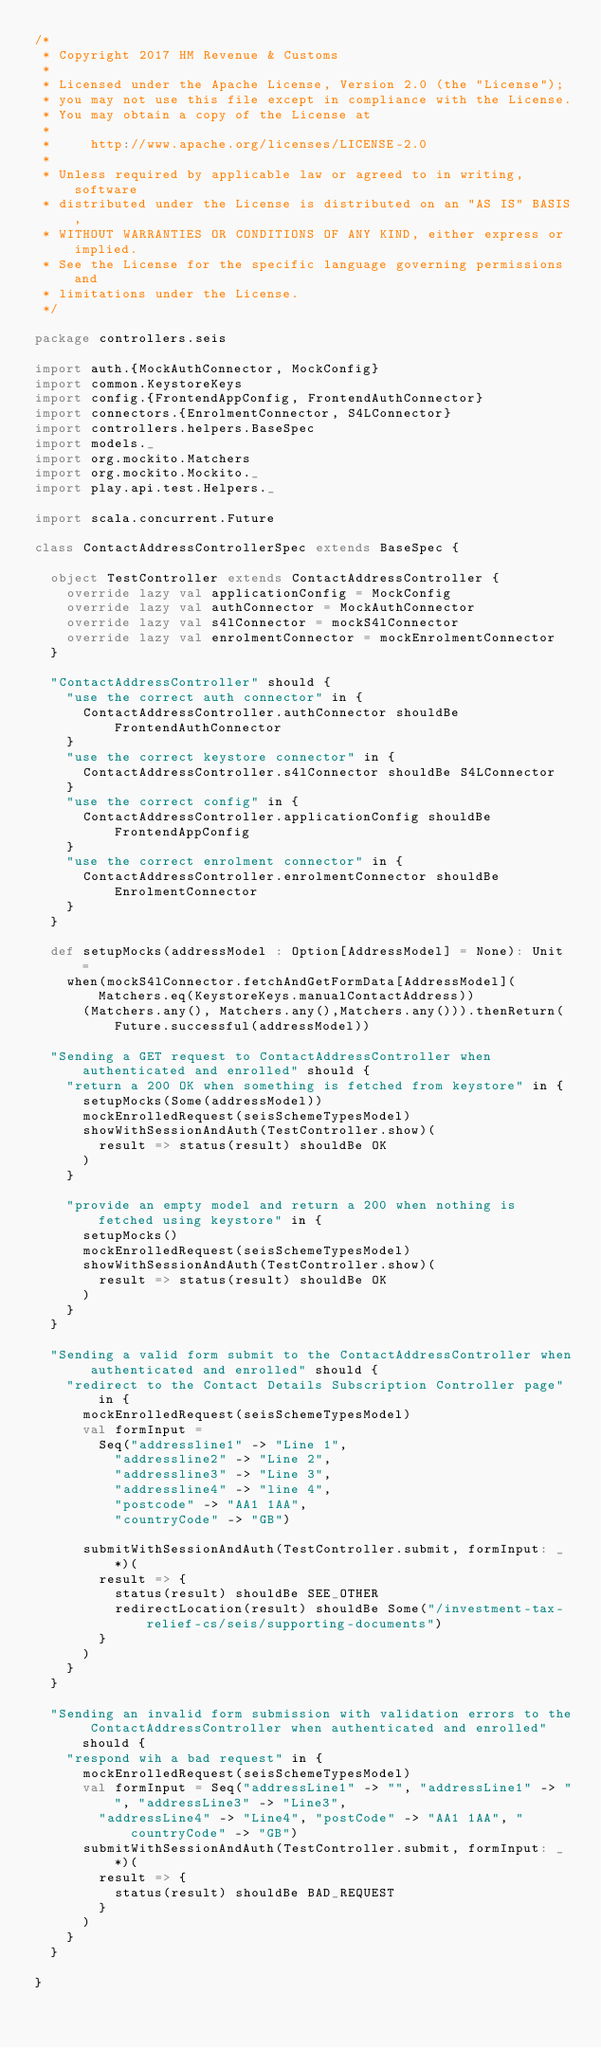<code> <loc_0><loc_0><loc_500><loc_500><_Scala_>/*
 * Copyright 2017 HM Revenue & Customs
 *
 * Licensed under the Apache License, Version 2.0 (the "License");
 * you may not use this file except in compliance with the License.
 * You may obtain a copy of the License at
 *
 *     http://www.apache.org/licenses/LICENSE-2.0
 *
 * Unless required by applicable law or agreed to in writing, software
 * distributed under the License is distributed on an "AS IS" BASIS,
 * WITHOUT WARRANTIES OR CONDITIONS OF ANY KIND, either express or implied.
 * See the License for the specific language governing permissions and
 * limitations under the License.
 */

package controllers.seis

import auth.{MockAuthConnector, MockConfig}
import common.KeystoreKeys
import config.{FrontendAppConfig, FrontendAuthConnector}
import connectors.{EnrolmentConnector, S4LConnector}
import controllers.helpers.BaseSpec
import models._
import org.mockito.Matchers
import org.mockito.Mockito._
import play.api.test.Helpers._

import scala.concurrent.Future

class ContactAddressControllerSpec extends BaseSpec {

  object TestController extends ContactAddressController {
    override lazy val applicationConfig = MockConfig
    override lazy val authConnector = MockAuthConnector
    override lazy val s4lConnector = mockS4lConnector
    override lazy val enrolmentConnector = mockEnrolmentConnector
  }

  "ContactAddressController" should {
    "use the correct auth connector" in {
      ContactAddressController.authConnector shouldBe FrontendAuthConnector
    }
    "use the correct keystore connector" in {
      ContactAddressController.s4lConnector shouldBe S4LConnector
    }
    "use the correct config" in {
      ContactAddressController.applicationConfig shouldBe FrontendAppConfig
    }
    "use the correct enrolment connector" in {
      ContactAddressController.enrolmentConnector shouldBe EnrolmentConnector
    }
  }

  def setupMocks(addressModel : Option[AddressModel] = None): Unit =
    when(mockS4lConnector.fetchAndGetFormData[AddressModel](Matchers.eq(KeystoreKeys.manualContactAddress))
      (Matchers.any(), Matchers.any(),Matchers.any())).thenReturn(Future.successful(addressModel))

  "Sending a GET request to ContactAddressController when authenticated and enrolled" should {
    "return a 200 OK when something is fetched from keystore" in {
      setupMocks(Some(addressModel))
      mockEnrolledRequest(seisSchemeTypesModel)
      showWithSessionAndAuth(TestController.show)(
        result => status(result) shouldBe OK
      )
    }

    "provide an empty model and return a 200 when nothing is fetched using keystore" in {
      setupMocks()
      mockEnrolledRequest(seisSchemeTypesModel)
      showWithSessionAndAuth(TestController.show)(
        result => status(result) shouldBe OK
      )
    }
  }

  "Sending a valid form submit to the ContactAddressController when authenticated and enrolled" should {
    "redirect to the Contact Details Subscription Controller page" in {
      mockEnrolledRequest(seisSchemeTypesModel)
      val formInput =
        Seq("addressline1" -> "Line 1",
          "addressline2" -> "Line 2",
          "addressline3" -> "Line 3",
          "addressline4" -> "line 4",
          "postcode" -> "AA1 1AA",
          "countryCode" -> "GB")

      submitWithSessionAndAuth(TestController.submit, formInput: _*)(
        result => {
          status(result) shouldBe SEE_OTHER
          redirectLocation(result) shouldBe Some("/investment-tax-relief-cs/seis/supporting-documents")
        }
      )
    }
  }

  "Sending an invalid form submission with validation errors to the ContactAddressController when authenticated and enrolled" should {
    "respond wih a bad request" in {
      mockEnrolledRequest(seisSchemeTypesModel)
      val formInput = Seq("addressLine1" -> "", "addressLine1" -> "", "addressLine3" -> "Line3",
        "addressLine4" -> "Line4", "postCode" -> "AA1 1AA", "countryCode" -> "GB")
      submitWithSessionAndAuth(TestController.submit, formInput: _*)(
        result => {
          status(result) shouldBe BAD_REQUEST
        }
      )
    }
  }

}
</code> 